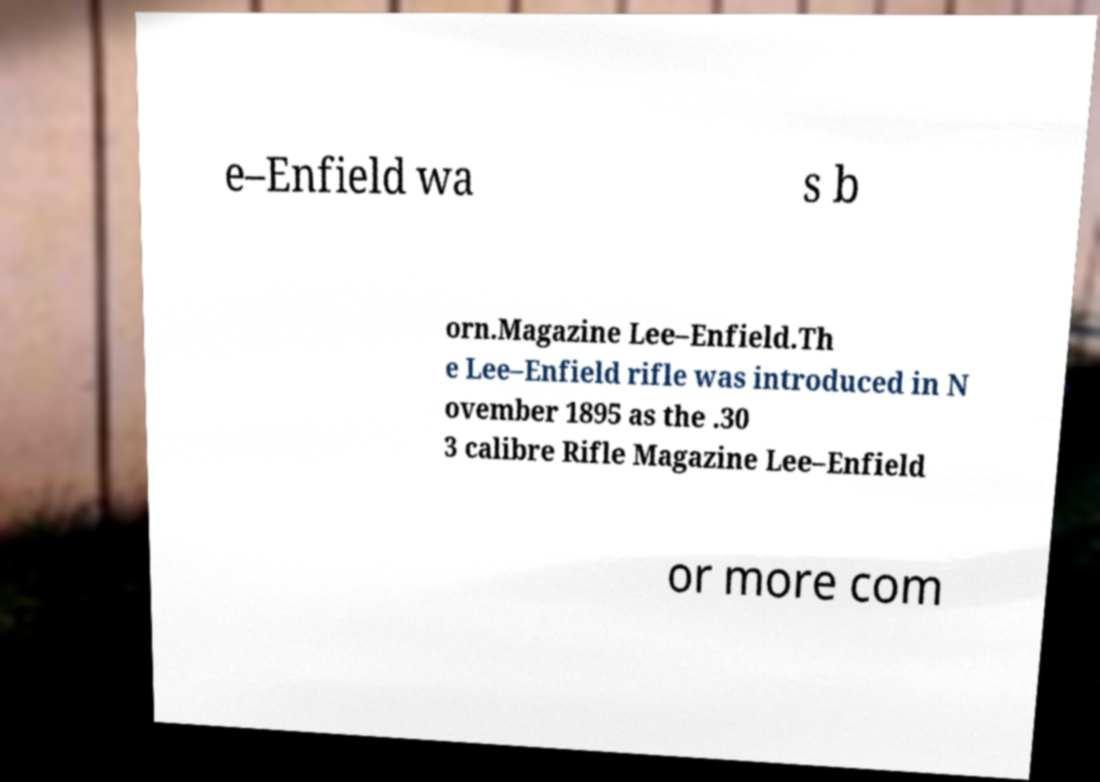Could you assist in decoding the text presented in this image and type it out clearly? e–Enfield wa s b orn.Magazine Lee–Enfield.Th e Lee–Enfield rifle was introduced in N ovember 1895 as the .30 3 calibre Rifle Magazine Lee–Enfield or more com 